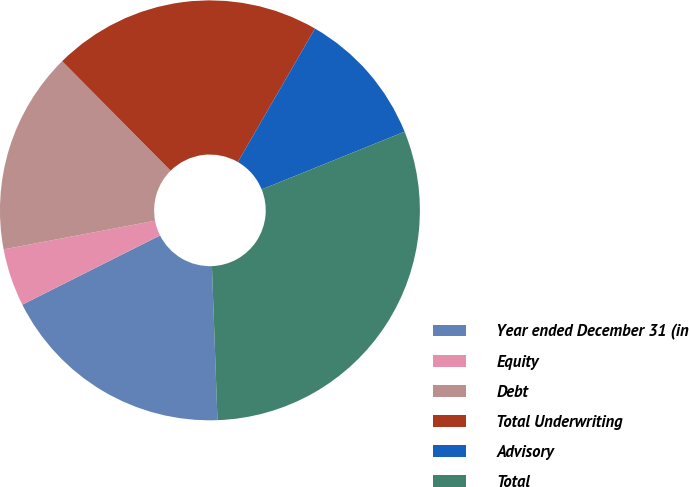<chart> <loc_0><loc_0><loc_500><loc_500><pie_chart><fcel>Year ended December 31 (in<fcel>Equity<fcel>Debt<fcel>Total Underwriting<fcel>Advisory<fcel>Total<nl><fcel>18.16%<fcel>4.44%<fcel>15.55%<fcel>20.77%<fcel>10.55%<fcel>30.54%<nl></chart> 